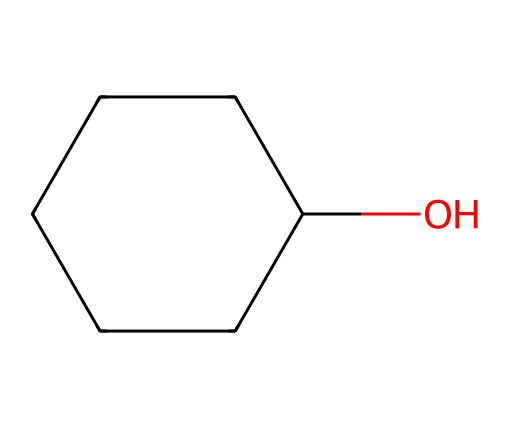How many carbon atoms are in cyclohexanol? The SMILES representation OC1CCCCC1 indicates there are six carbon atoms represented by the "C" in the ring.
Answer: six What is the functional group present in cyclohexanol? The "O" in the SMILES indicates that there is a hydroxyl (-OH) group attached to one of the carbon atoms, which characterizes cyclohexanol as an alcohol.
Answer: hydroxyl How many hydrogen atoms are in cyclohexanol? Each carbon in cyclohexanol is bonded to hydrogen atoms. Since there are six carbons and one hydroxyl group, the total number of hydrogen atoms is 12. The formula can be derived as CnH2n+1OH, which gives C6H12O, leading to twelve hydrogen atoms.
Answer: twelve What type of ring structure is present in cyclohexanol? The number "1" in the SMILES denotes the start and the end of the ring, indicating that it is a cyclic structure. The presence of only single bonds between carbon atoms shows it's a saturated cycloalkane.
Answer: cyclohexane What kind of chemical is cyclohexanol? Cyclohexanol is classified as a cycloalkanol because it is a cyclic structure (cyclo-) containing a hydroxyl functional group (-ol) attached to it.
Answer: cycloalkanol Is cyclohexanol saturated or unsaturated? The presence of only single bonds and no double bonds in the structure confirms that cyclohexanol is saturated.
Answer: saturated 